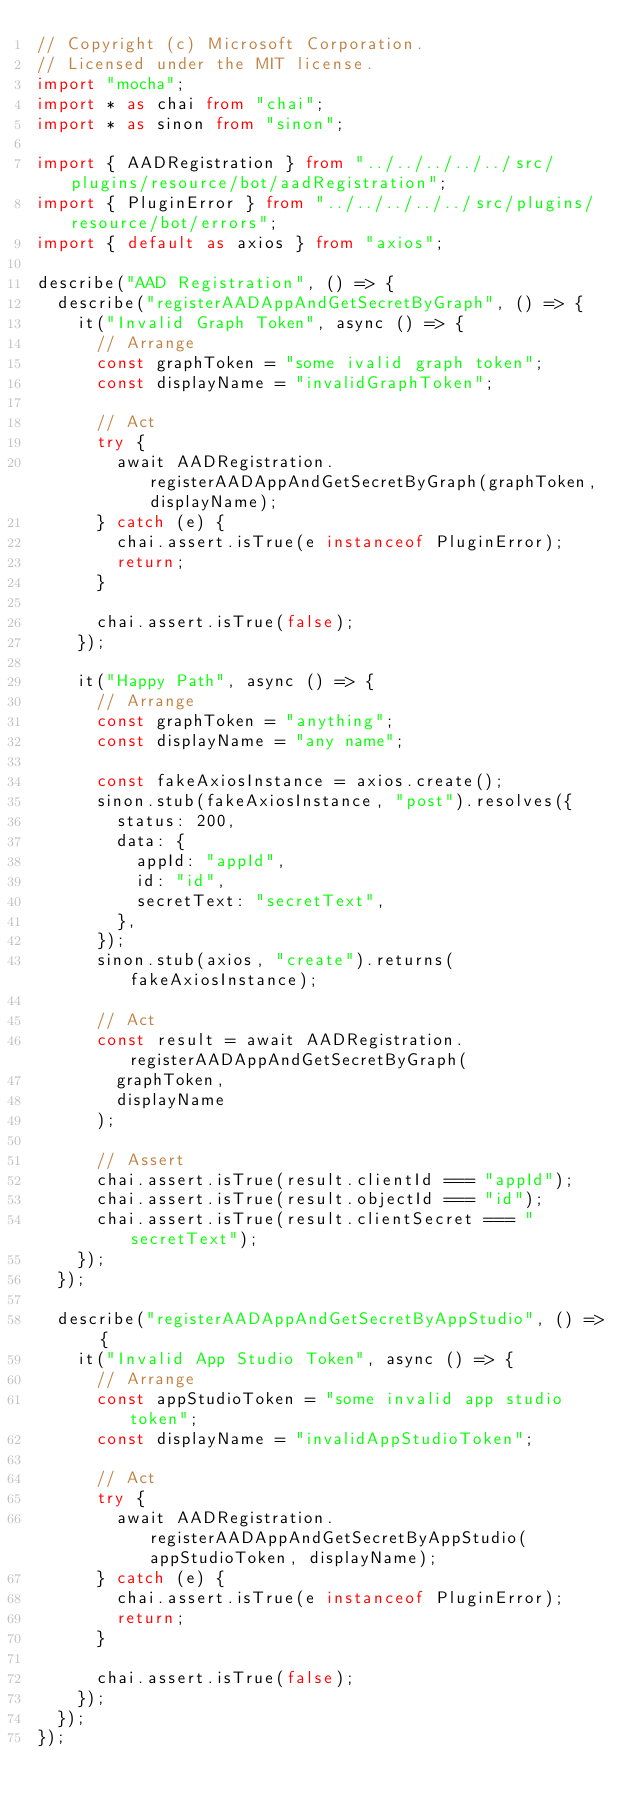Convert code to text. <code><loc_0><loc_0><loc_500><loc_500><_TypeScript_>// Copyright (c) Microsoft Corporation.
// Licensed under the MIT license.
import "mocha";
import * as chai from "chai";
import * as sinon from "sinon";

import { AADRegistration } from "../../../../../src/plugins/resource/bot/aadRegistration";
import { PluginError } from "../../../../../src/plugins/resource/bot/errors";
import { default as axios } from "axios";

describe("AAD Registration", () => {
  describe("registerAADAppAndGetSecretByGraph", () => {
    it("Invalid Graph Token", async () => {
      // Arrange
      const graphToken = "some ivalid graph token";
      const displayName = "invalidGraphToken";

      // Act
      try {
        await AADRegistration.registerAADAppAndGetSecretByGraph(graphToken, displayName);
      } catch (e) {
        chai.assert.isTrue(e instanceof PluginError);
        return;
      }

      chai.assert.isTrue(false);
    });

    it("Happy Path", async () => {
      // Arrange
      const graphToken = "anything";
      const displayName = "any name";

      const fakeAxiosInstance = axios.create();
      sinon.stub(fakeAxiosInstance, "post").resolves({
        status: 200,
        data: {
          appId: "appId",
          id: "id",
          secretText: "secretText",
        },
      });
      sinon.stub(axios, "create").returns(fakeAxiosInstance);

      // Act
      const result = await AADRegistration.registerAADAppAndGetSecretByGraph(
        graphToken,
        displayName
      );

      // Assert
      chai.assert.isTrue(result.clientId === "appId");
      chai.assert.isTrue(result.objectId === "id");
      chai.assert.isTrue(result.clientSecret === "secretText");
    });
  });

  describe("registerAADAppAndGetSecretByAppStudio", () => {
    it("Invalid App Studio Token", async () => {
      // Arrange
      const appStudioToken = "some invalid app studio token";
      const displayName = "invalidAppStudioToken";

      // Act
      try {
        await AADRegistration.registerAADAppAndGetSecretByAppStudio(appStudioToken, displayName);
      } catch (e) {
        chai.assert.isTrue(e instanceof PluginError);
        return;
      }

      chai.assert.isTrue(false);
    });
  });
});
</code> 